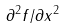Convert formula to latex. <formula><loc_0><loc_0><loc_500><loc_500>\partial ^ { 2 } f / \partial x ^ { 2 }</formula> 